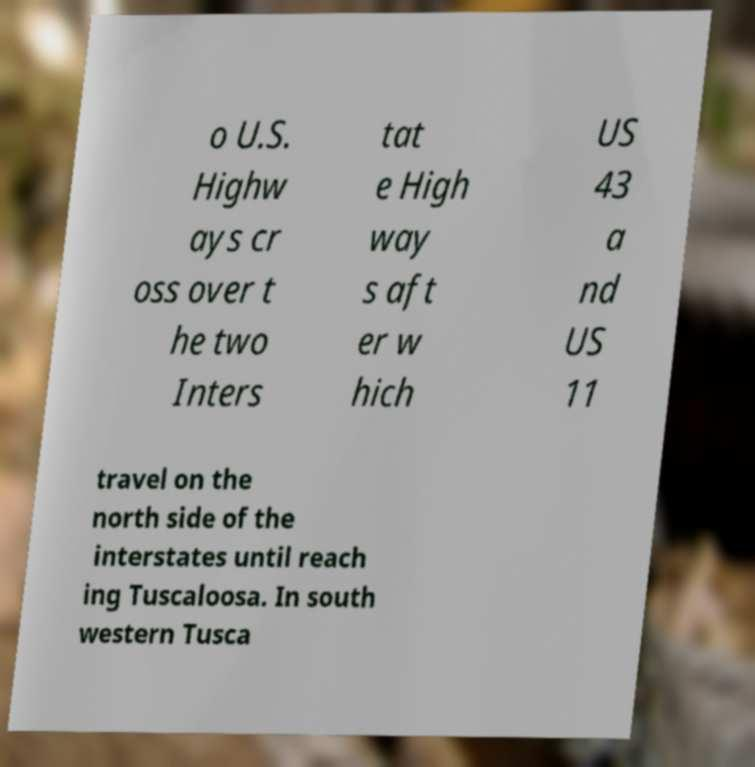What messages or text are displayed in this image? I need them in a readable, typed format. o U.S. Highw ays cr oss over t he two Inters tat e High way s aft er w hich US 43 a nd US 11 travel on the north side of the interstates until reach ing Tuscaloosa. In south western Tusca 